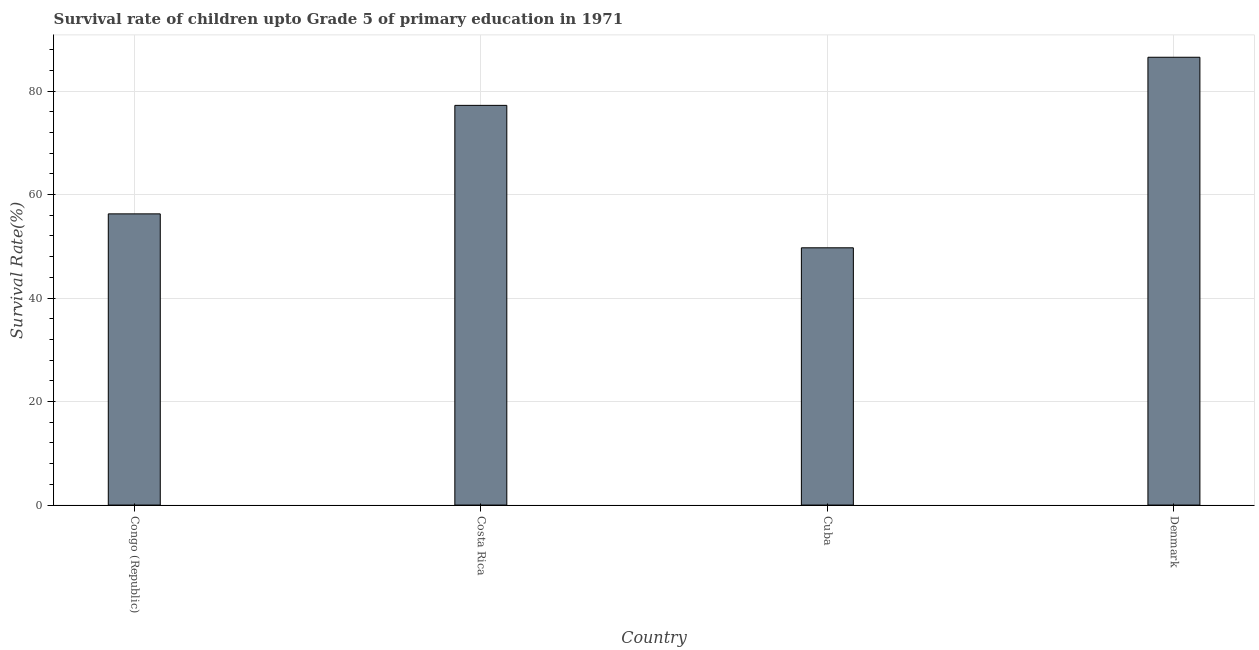Does the graph contain any zero values?
Keep it short and to the point. No. What is the title of the graph?
Provide a succinct answer. Survival rate of children upto Grade 5 of primary education in 1971 . What is the label or title of the Y-axis?
Make the answer very short. Survival Rate(%). What is the survival rate in Cuba?
Keep it short and to the point. 49.71. Across all countries, what is the maximum survival rate?
Your answer should be very brief. 86.53. Across all countries, what is the minimum survival rate?
Your response must be concise. 49.71. In which country was the survival rate maximum?
Make the answer very short. Denmark. In which country was the survival rate minimum?
Your response must be concise. Cuba. What is the sum of the survival rate?
Provide a succinct answer. 269.74. What is the difference between the survival rate in Costa Rica and Denmark?
Give a very brief answer. -9.3. What is the average survival rate per country?
Make the answer very short. 67.43. What is the median survival rate?
Provide a short and direct response. 66.75. What is the ratio of the survival rate in Cuba to that in Denmark?
Provide a short and direct response. 0.57. What is the difference between the highest and the second highest survival rate?
Provide a short and direct response. 9.3. What is the difference between the highest and the lowest survival rate?
Your answer should be very brief. 36.82. What is the difference between two consecutive major ticks on the Y-axis?
Ensure brevity in your answer.  20. Are the values on the major ticks of Y-axis written in scientific E-notation?
Give a very brief answer. No. What is the Survival Rate(%) of Congo (Republic)?
Keep it short and to the point. 56.27. What is the Survival Rate(%) in Costa Rica?
Make the answer very short. 77.23. What is the Survival Rate(%) in Cuba?
Offer a very short reply. 49.71. What is the Survival Rate(%) of Denmark?
Your answer should be very brief. 86.53. What is the difference between the Survival Rate(%) in Congo (Republic) and Costa Rica?
Provide a short and direct response. -20.97. What is the difference between the Survival Rate(%) in Congo (Republic) and Cuba?
Offer a terse response. 6.55. What is the difference between the Survival Rate(%) in Congo (Republic) and Denmark?
Provide a succinct answer. -30.26. What is the difference between the Survival Rate(%) in Costa Rica and Cuba?
Your answer should be very brief. 27.52. What is the difference between the Survival Rate(%) in Costa Rica and Denmark?
Keep it short and to the point. -9.3. What is the difference between the Survival Rate(%) in Cuba and Denmark?
Keep it short and to the point. -36.82. What is the ratio of the Survival Rate(%) in Congo (Republic) to that in Costa Rica?
Your answer should be compact. 0.73. What is the ratio of the Survival Rate(%) in Congo (Republic) to that in Cuba?
Your answer should be very brief. 1.13. What is the ratio of the Survival Rate(%) in Congo (Republic) to that in Denmark?
Offer a terse response. 0.65. What is the ratio of the Survival Rate(%) in Costa Rica to that in Cuba?
Keep it short and to the point. 1.55. What is the ratio of the Survival Rate(%) in Costa Rica to that in Denmark?
Your answer should be compact. 0.89. What is the ratio of the Survival Rate(%) in Cuba to that in Denmark?
Keep it short and to the point. 0.57. 